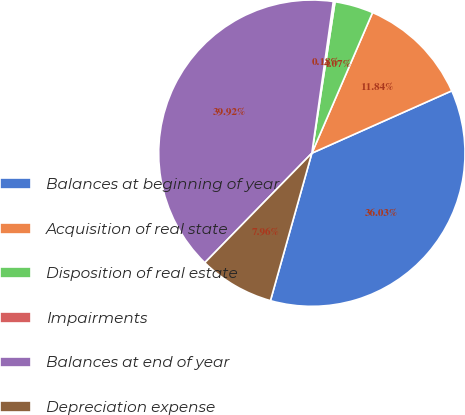Convert chart. <chart><loc_0><loc_0><loc_500><loc_500><pie_chart><fcel>Balances at beginning of year<fcel>Acquisition of real state<fcel>Disposition of real estate<fcel>Impairments<fcel>Balances at end of year<fcel>Depreciation expense<nl><fcel>36.03%<fcel>11.84%<fcel>4.07%<fcel>0.18%<fcel>39.92%<fcel>7.96%<nl></chart> 